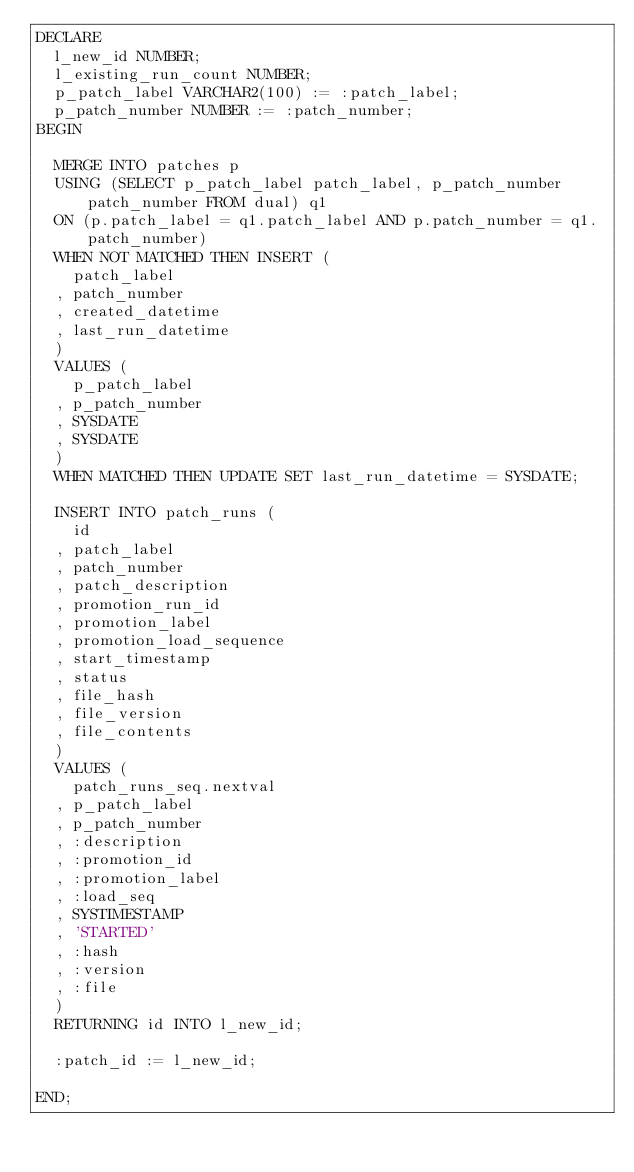<code> <loc_0><loc_0><loc_500><loc_500><_SQL_>DECLARE
  l_new_id NUMBER;
  l_existing_run_count NUMBER;
  p_patch_label VARCHAR2(100) := :patch_label;
  p_patch_number NUMBER := :patch_number;
BEGIN

  MERGE INTO patches p
  USING (SELECT p_patch_label patch_label, p_patch_number patch_number FROM dual) q1
  ON (p.patch_label = q1.patch_label AND p.patch_number = q1.patch_number)
  WHEN NOT MATCHED THEN INSERT (
    patch_label
  , patch_number
  , created_datetime
  , last_run_datetime
  )
  VALUES (
    p_patch_label
  , p_patch_number
  , SYSDATE
  , SYSDATE
  )
  WHEN MATCHED THEN UPDATE SET last_run_datetime = SYSDATE;

  INSERT INTO patch_runs (
    id
  , patch_label
  , patch_number
  , patch_description
  , promotion_run_id
  , promotion_label
  , promotion_load_sequence
  , start_timestamp
  , status
  , file_hash
  , file_version
  , file_contents
  )
  VALUES (
    patch_runs_seq.nextval
  , p_patch_label
  , p_patch_number
  , :description
  , :promotion_id
  , :promotion_label
  , :load_seq
  , SYSTIMESTAMP
  , 'STARTED'
  , :hash
  , :version
  , :file
  )
  RETURNING id INTO l_new_id;
  
  :patch_id := l_new_id;  
  
END;</code> 